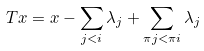Convert formula to latex. <formula><loc_0><loc_0><loc_500><loc_500>T x = x - \sum _ { j < i } \lambda _ { j } + \sum _ { \pi j < \pi i } \lambda _ { j }</formula> 